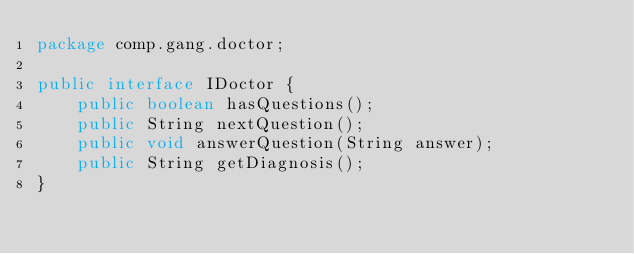Convert code to text. <code><loc_0><loc_0><loc_500><loc_500><_Java_>package comp.gang.doctor;

public interface IDoctor {
    public boolean hasQuestions();
    public String nextQuestion();
    public void answerQuestion(String answer);
    public String getDiagnosis();
}
</code> 